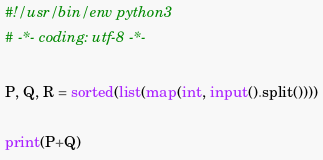Convert code to text. <code><loc_0><loc_0><loc_500><loc_500><_Python_>#!/usr/bin/env python3
# -*- coding: utf-8 -*-

P, Q, R = sorted(list(map(int, input().split())))

print(P+Q)
</code> 